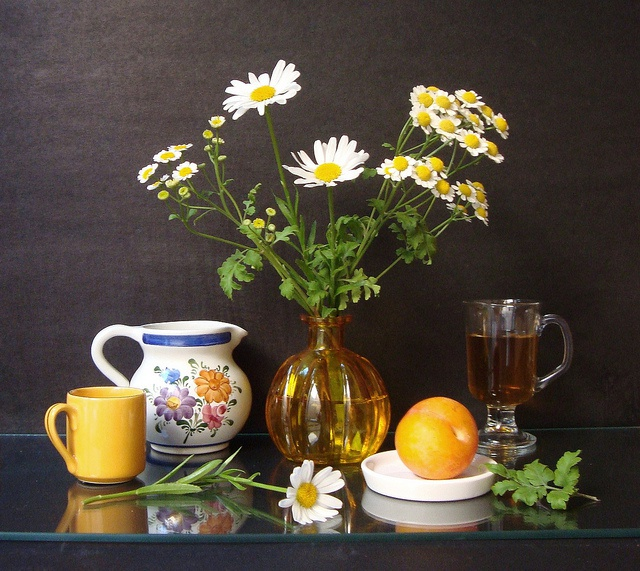Describe the objects in this image and their specific colors. I can see vase in gray, maroon, olive, and black tones, cup in gray, black, and maroon tones, cup in gray, gold, orange, and olive tones, and orange in gray, orange, and gold tones in this image. 